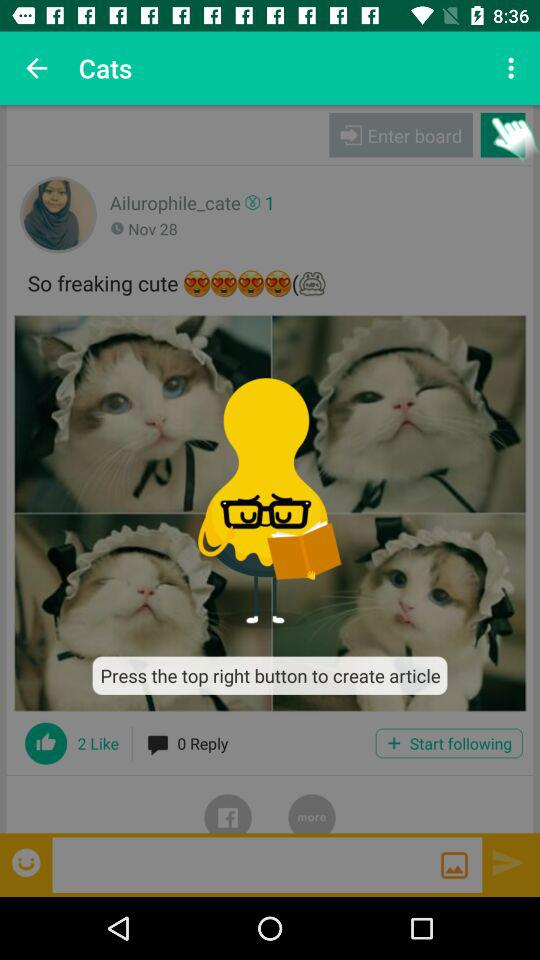How many more likes does the article have than comments?
Answer the question using a single word or phrase. 2 